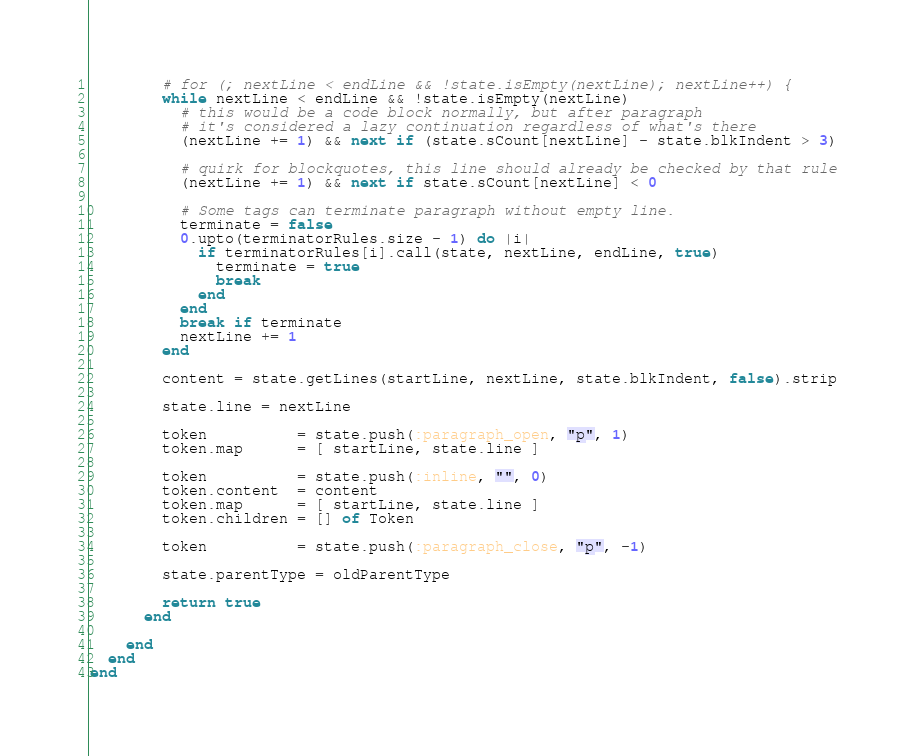Convert code to text. <code><loc_0><loc_0><loc_500><loc_500><_Crystal_>        # for (; nextLine < endLine && !state.isEmpty(nextLine); nextLine++) {
        while nextLine < endLine && !state.isEmpty(nextLine)
          # this would be a code block normally, but after paragraph
          # it's considered a lazy continuation regardless of what's there
          (nextLine += 1) && next if (state.sCount[nextLine] - state.blkIndent > 3)

          # quirk for blockquotes, this line should already be checked by that rule
          (nextLine += 1) && next if state.sCount[nextLine] < 0

          # Some tags can terminate paragraph without empty line.
          terminate = false
          0.upto(terminatorRules.size - 1) do |i|
            if terminatorRules[i].call(state, nextLine, endLine, true)
              terminate = true
              break
            end
          end
          break if terminate
          nextLine += 1
        end

        content = state.getLines(startLine, nextLine, state.blkIndent, false).strip

        state.line = nextLine

        token          = state.push(:paragraph_open, "p", 1)
        token.map      = [ startLine, state.line ]

        token          = state.push(:inline, "", 0)
        token.content  = content
        token.map      = [ startLine, state.line ]
        token.children = [] of Token

        token          = state.push(:paragraph_close, "p", -1)

        state.parentType = oldParentType

        return true
      end

    end
  end
end
</code> 